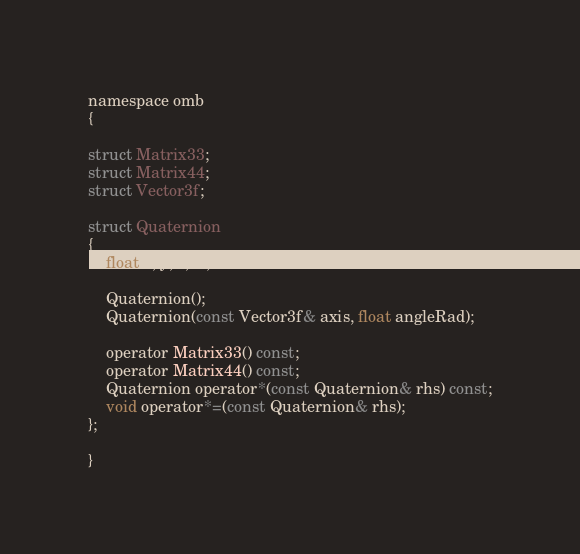Convert code to text. <code><loc_0><loc_0><loc_500><loc_500><_C_>
namespace omb
{

struct Matrix33;
struct Matrix44;
struct Vector3f;

struct Quaternion
{
	float x, y, z, w;
	
	Quaternion();
	Quaternion(const Vector3f& axis, float angleRad);
	
	operator Matrix33() const;
	operator Matrix44() const;
	Quaternion operator*(const Quaternion& rhs) const;
	void operator*=(const Quaternion& rhs);
};
	
}
</code> 